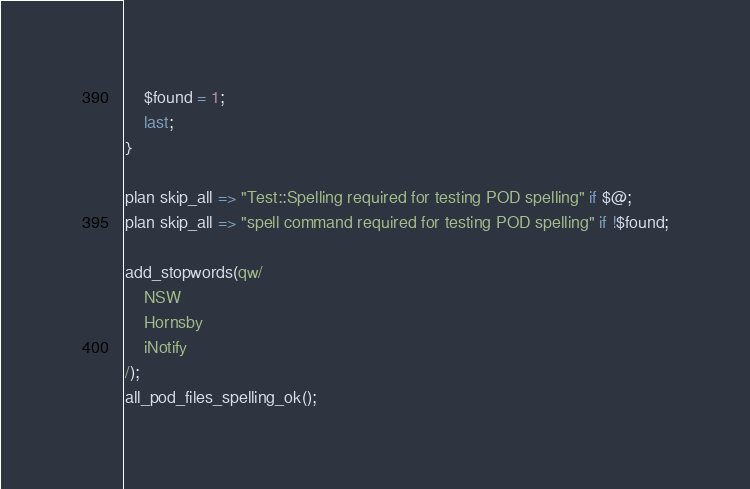Convert code to text. <code><loc_0><loc_0><loc_500><loc_500><_Perl_>    $found = 1;
    last;
}

plan skip_all => "Test::Spelling required for testing POD spelling" if $@;
plan skip_all => "spell command required for testing POD spelling" if !$found;

add_stopwords(qw/
    NSW
    Hornsby
    iNotify
/);
all_pod_files_spelling_ok();
</code> 